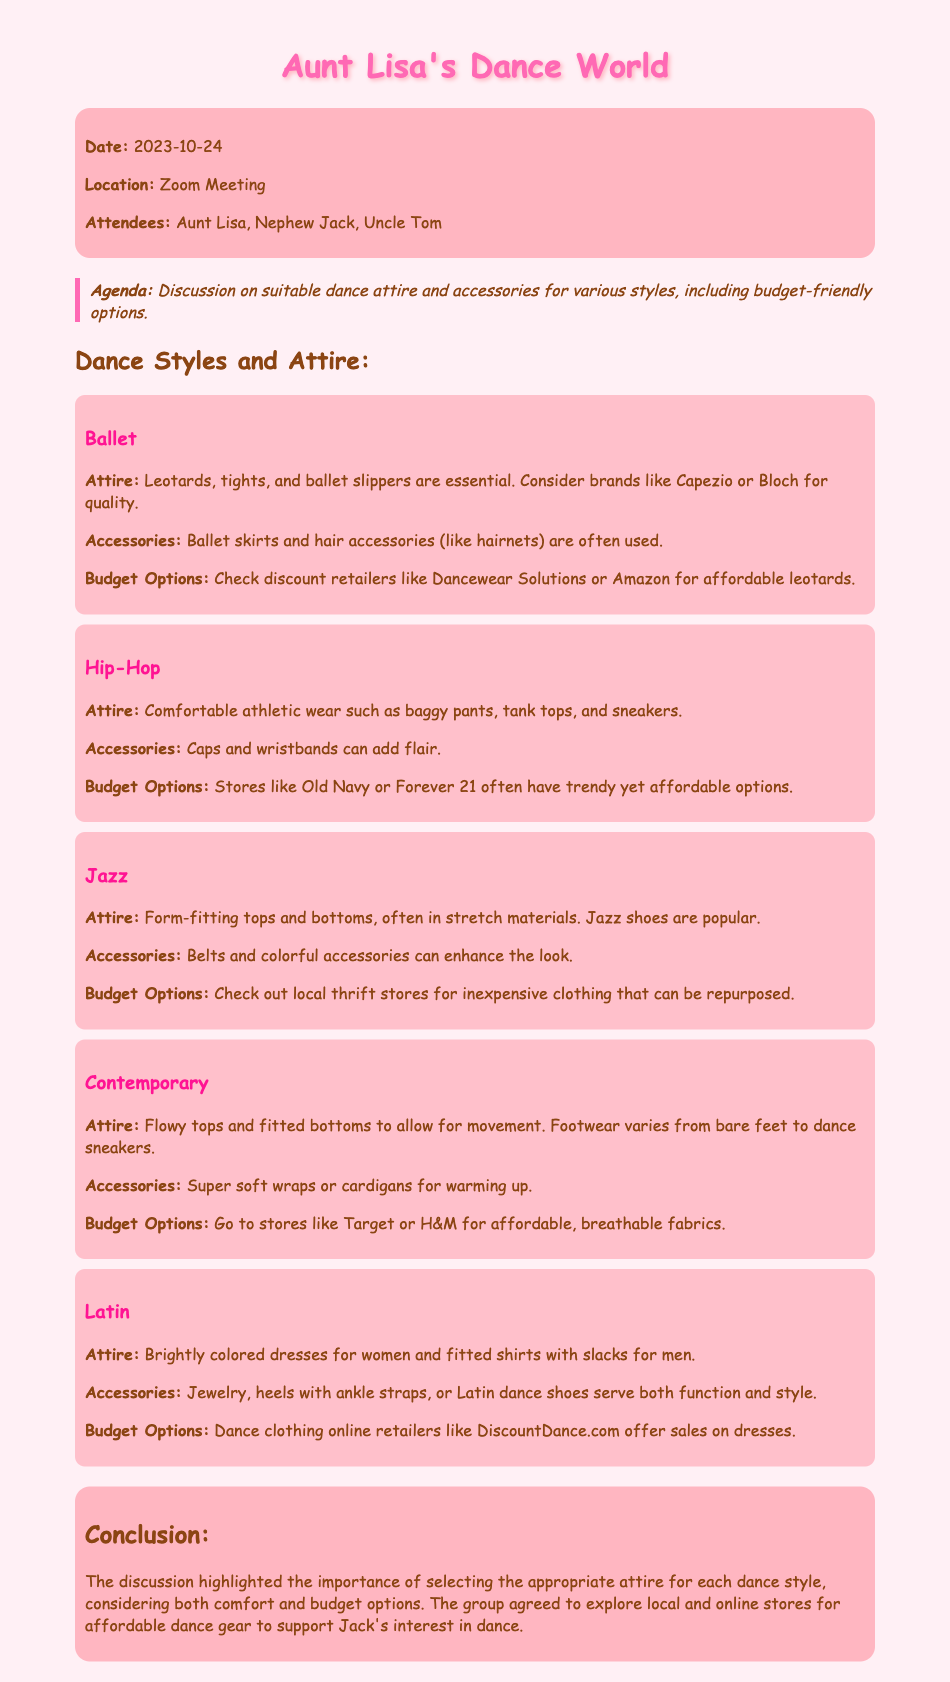What date was the meeting held? The date of the meeting is explicitly stated at the beginning of the document.
Answer: 2023-10-24 Who attended the meeting? The names of the attendees are listed in the document.
Answer: Aunt Lisa, Nephew Jack, Uncle Tom What is the main agenda of the meeting? The agenda is outlined in a specific section of the document highlighting the focus of the discussion.
Answer: Discussion on suitable dance attire and accessories for various styles, including budget-friendly options Which dance style requires leotards and ballet slippers? This information is specified under the section detailing attire for each dance style.
Answer: Ballet What budget-friendly option is suggested for ballet attire? The document includes specific recommendations for finding affordable ballet attire.
Answer: Dancewear Solutions or Amazon What type of attire is suggested for Hip-Hop dancing? The document describes the attire categories for each style, including Hip-Hop.
Answer: Comfortable athletic wear such as baggy pants, tank tops, and sneakers Which store is recommended for affordable contemporary dance attire? The budget options for each style include specific stores for purchase.
Answer: Target or H&M What accessories are suggested for Latin dance? This information is provided under the Latin dance style section regarding attire and accessories.
Answer: Jewelry, heels with ankle straps, or Latin dance shoes What was the conclusion of the discussion? The conclusion summarizes the key points and agreements made during the meeting.
Answer: The discussion highlighted the importance of selecting the appropriate attire for each dance style, considering both comfort and budget options 